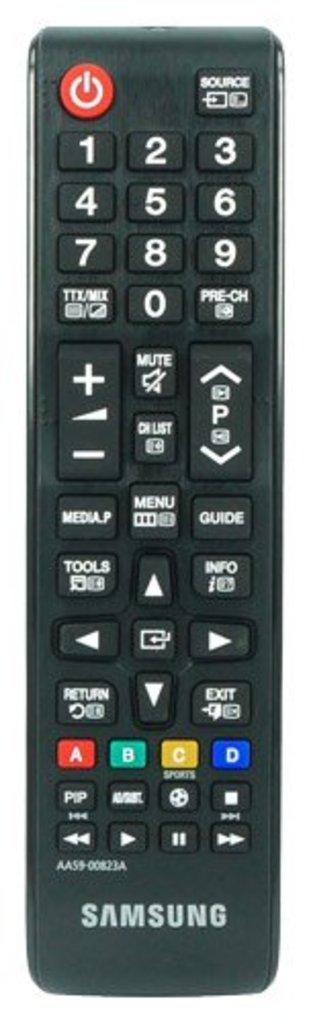<image>
Provide a brief description of the given image. a Samsung remote control has buttons on it like Source and Return 